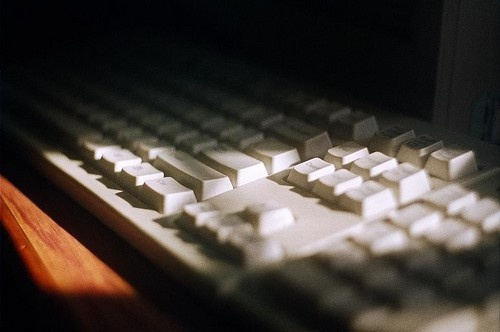Describe the objects in this image and their specific colors. I can see a keyboard in black, lightgray, and gray tones in this image. 